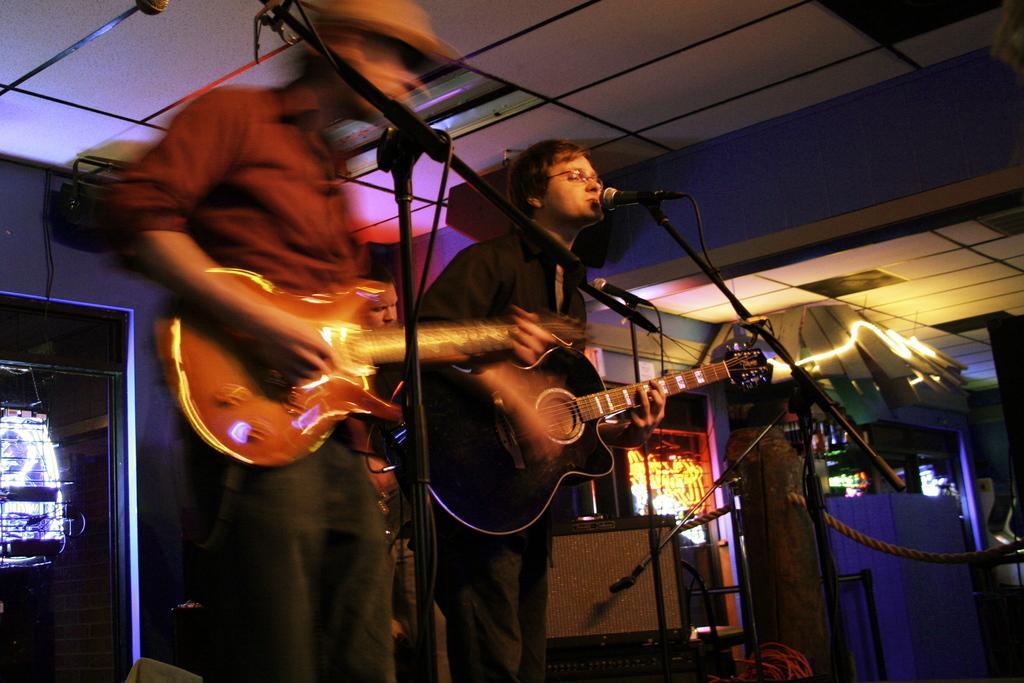Could you give a brief overview of what you see in this image? In this image there are three men performing live music with guitars in there hand, in front of them there are mice, in the background there is wall for that wall there are doors, in the top there is a ceiling. 